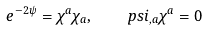Convert formula to latex. <formula><loc_0><loc_0><loc_500><loc_500>e ^ { - 2 \psi } = \chi ^ { a } \chi _ { a } , \quad p s i _ { , a } \chi ^ { a } = 0</formula> 